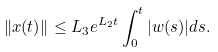Convert formula to latex. <formula><loc_0><loc_0><loc_500><loc_500>\| x ( t ) \| \leq L _ { 3 } e ^ { L _ { 2 } t } \int _ { 0 } ^ { t } | w ( s ) | d s .</formula> 